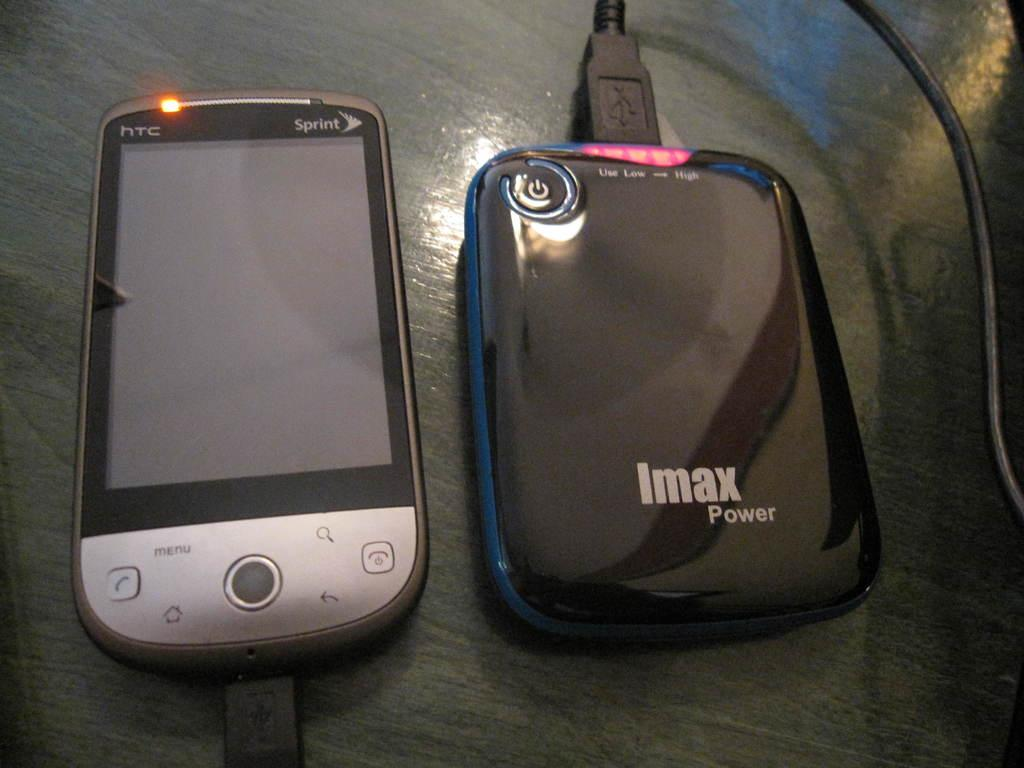Provide a one-sentence caption for the provided image. An HTC Sprint phone and IMAX Power charger. 